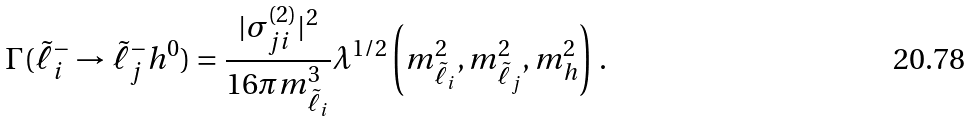Convert formula to latex. <formula><loc_0><loc_0><loc_500><loc_500>\Gamma ( \tilde { \ell } _ { i } ^ { - } \to \tilde { \ell } _ { j } ^ { - } h ^ { 0 } ) = \frac { | \sigma _ { j i } ^ { ( 2 ) } | ^ { 2 } } { 1 6 \pi m _ { \tilde { \ell } _ { i } } ^ { 3 } } \lambda ^ { 1 / 2 } \left ( m _ { \tilde { \ell } _ { i } } ^ { 2 } , m _ { \tilde { \ell } _ { j } } ^ { 2 } , m _ { h } ^ { 2 } \right ) \, .</formula> 